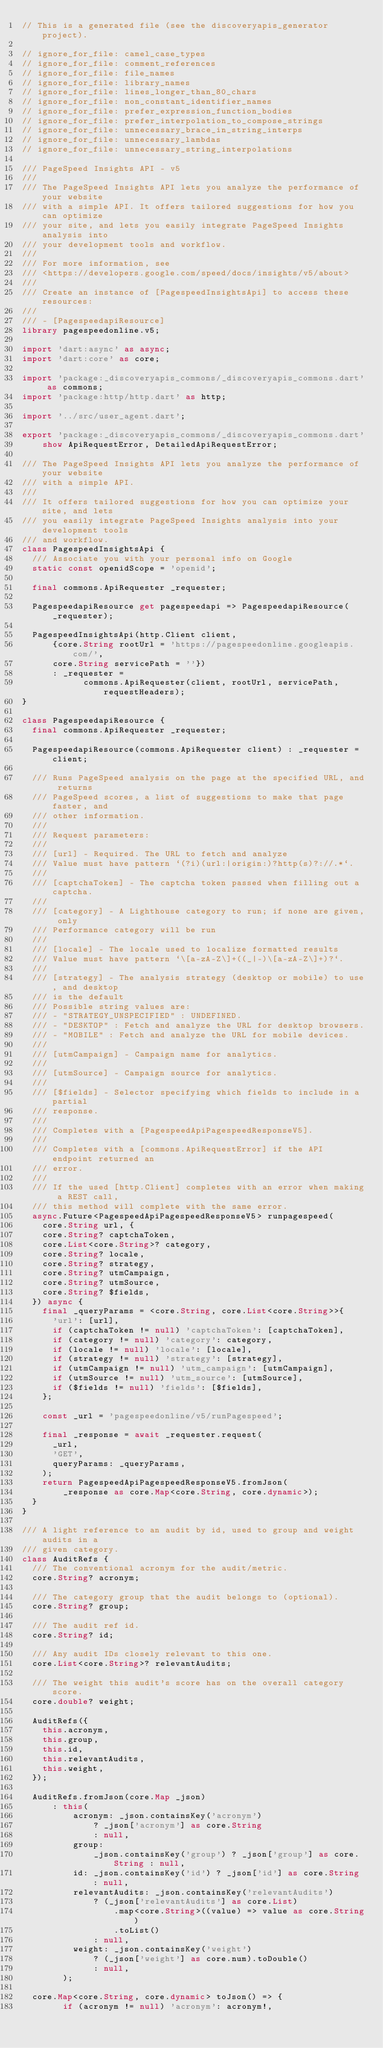Convert code to text. <code><loc_0><loc_0><loc_500><loc_500><_Dart_>// This is a generated file (see the discoveryapis_generator project).

// ignore_for_file: camel_case_types
// ignore_for_file: comment_references
// ignore_for_file: file_names
// ignore_for_file: library_names
// ignore_for_file: lines_longer_than_80_chars
// ignore_for_file: non_constant_identifier_names
// ignore_for_file: prefer_expression_function_bodies
// ignore_for_file: prefer_interpolation_to_compose_strings
// ignore_for_file: unnecessary_brace_in_string_interps
// ignore_for_file: unnecessary_lambdas
// ignore_for_file: unnecessary_string_interpolations

/// PageSpeed Insights API - v5
///
/// The PageSpeed Insights API lets you analyze the performance of your website
/// with a simple API. It offers tailored suggestions for how you can optimize
/// your site, and lets you easily integrate PageSpeed Insights analysis into
/// your development tools and workflow.
///
/// For more information, see
/// <https://developers.google.com/speed/docs/insights/v5/about>
///
/// Create an instance of [PagespeedInsightsApi] to access these resources:
///
/// - [PagespeedapiResource]
library pagespeedonline.v5;

import 'dart:async' as async;
import 'dart:core' as core;

import 'package:_discoveryapis_commons/_discoveryapis_commons.dart' as commons;
import 'package:http/http.dart' as http;

import '../src/user_agent.dart';

export 'package:_discoveryapis_commons/_discoveryapis_commons.dart'
    show ApiRequestError, DetailedApiRequestError;

/// The PageSpeed Insights API lets you analyze the performance of your website
/// with a simple API.
///
/// It offers tailored suggestions for how you can optimize your site, and lets
/// you easily integrate PageSpeed Insights analysis into your development tools
/// and workflow.
class PagespeedInsightsApi {
  /// Associate you with your personal info on Google
  static const openidScope = 'openid';

  final commons.ApiRequester _requester;

  PagespeedapiResource get pagespeedapi => PagespeedapiResource(_requester);

  PagespeedInsightsApi(http.Client client,
      {core.String rootUrl = 'https://pagespeedonline.googleapis.com/',
      core.String servicePath = ''})
      : _requester =
            commons.ApiRequester(client, rootUrl, servicePath, requestHeaders);
}

class PagespeedapiResource {
  final commons.ApiRequester _requester;

  PagespeedapiResource(commons.ApiRequester client) : _requester = client;

  /// Runs PageSpeed analysis on the page at the specified URL, and returns
  /// PageSpeed scores, a list of suggestions to make that page faster, and
  /// other information.
  ///
  /// Request parameters:
  ///
  /// [url] - Required. The URL to fetch and analyze
  /// Value must have pattern `(?i)(url:|origin:)?http(s)?://.*`.
  ///
  /// [captchaToken] - The captcha token passed when filling out a captcha.
  ///
  /// [category] - A Lighthouse category to run; if none are given, only
  /// Performance category will be run
  ///
  /// [locale] - The locale used to localize formatted results
  /// Value must have pattern `\[a-zA-Z\]+((_|-)\[a-zA-Z\]+)?`.
  ///
  /// [strategy] - The analysis strategy (desktop or mobile) to use, and desktop
  /// is the default
  /// Possible string values are:
  /// - "STRATEGY_UNSPECIFIED" : UNDEFINED.
  /// - "DESKTOP" : Fetch and analyze the URL for desktop browsers.
  /// - "MOBILE" : Fetch and analyze the URL for mobile devices.
  ///
  /// [utmCampaign] - Campaign name for analytics.
  ///
  /// [utmSource] - Campaign source for analytics.
  ///
  /// [$fields] - Selector specifying which fields to include in a partial
  /// response.
  ///
  /// Completes with a [PagespeedApiPagespeedResponseV5].
  ///
  /// Completes with a [commons.ApiRequestError] if the API endpoint returned an
  /// error.
  ///
  /// If the used [http.Client] completes with an error when making a REST call,
  /// this method will complete with the same error.
  async.Future<PagespeedApiPagespeedResponseV5> runpagespeed(
    core.String url, {
    core.String? captchaToken,
    core.List<core.String>? category,
    core.String? locale,
    core.String? strategy,
    core.String? utmCampaign,
    core.String? utmSource,
    core.String? $fields,
  }) async {
    final _queryParams = <core.String, core.List<core.String>>{
      'url': [url],
      if (captchaToken != null) 'captchaToken': [captchaToken],
      if (category != null) 'category': category,
      if (locale != null) 'locale': [locale],
      if (strategy != null) 'strategy': [strategy],
      if (utmCampaign != null) 'utm_campaign': [utmCampaign],
      if (utmSource != null) 'utm_source': [utmSource],
      if ($fields != null) 'fields': [$fields],
    };

    const _url = 'pagespeedonline/v5/runPagespeed';

    final _response = await _requester.request(
      _url,
      'GET',
      queryParams: _queryParams,
    );
    return PagespeedApiPagespeedResponseV5.fromJson(
        _response as core.Map<core.String, core.dynamic>);
  }
}

/// A light reference to an audit by id, used to group and weight audits in a
/// given category.
class AuditRefs {
  /// The conventional acronym for the audit/metric.
  core.String? acronym;

  /// The category group that the audit belongs to (optional).
  core.String? group;

  /// The audit ref id.
  core.String? id;

  /// Any audit IDs closely relevant to this one.
  core.List<core.String>? relevantAudits;

  /// The weight this audit's score has on the overall category score.
  core.double? weight;

  AuditRefs({
    this.acronym,
    this.group,
    this.id,
    this.relevantAudits,
    this.weight,
  });

  AuditRefs.fromJson(core.Map _json)
      : this(
          acronym: _json.containsKey('acronym')
              ? _json['acronym'] as core.String
              : null,
          group:
              _json.containsKey('group') ? _json['group'] as core.String : null,
          id: _json.containsKey('id') ? _json['id'] as core.String : null,
          relevantAudits: _json.containsKey('relevantAudits')
              ? (_json['relevantAudits'] as core.List)
                  .map<core.String>((value) => value as core.String)
                  .toList()
              : null,
          weight: _json.containsKey('weight')
              ? (_json['weight'] as core.num).toDouble()
              : null,
        );

  core.Map<core.String, core.dynamic> toJson() => {
        if (acronym != null) 'acronym': acronym!,</code> 